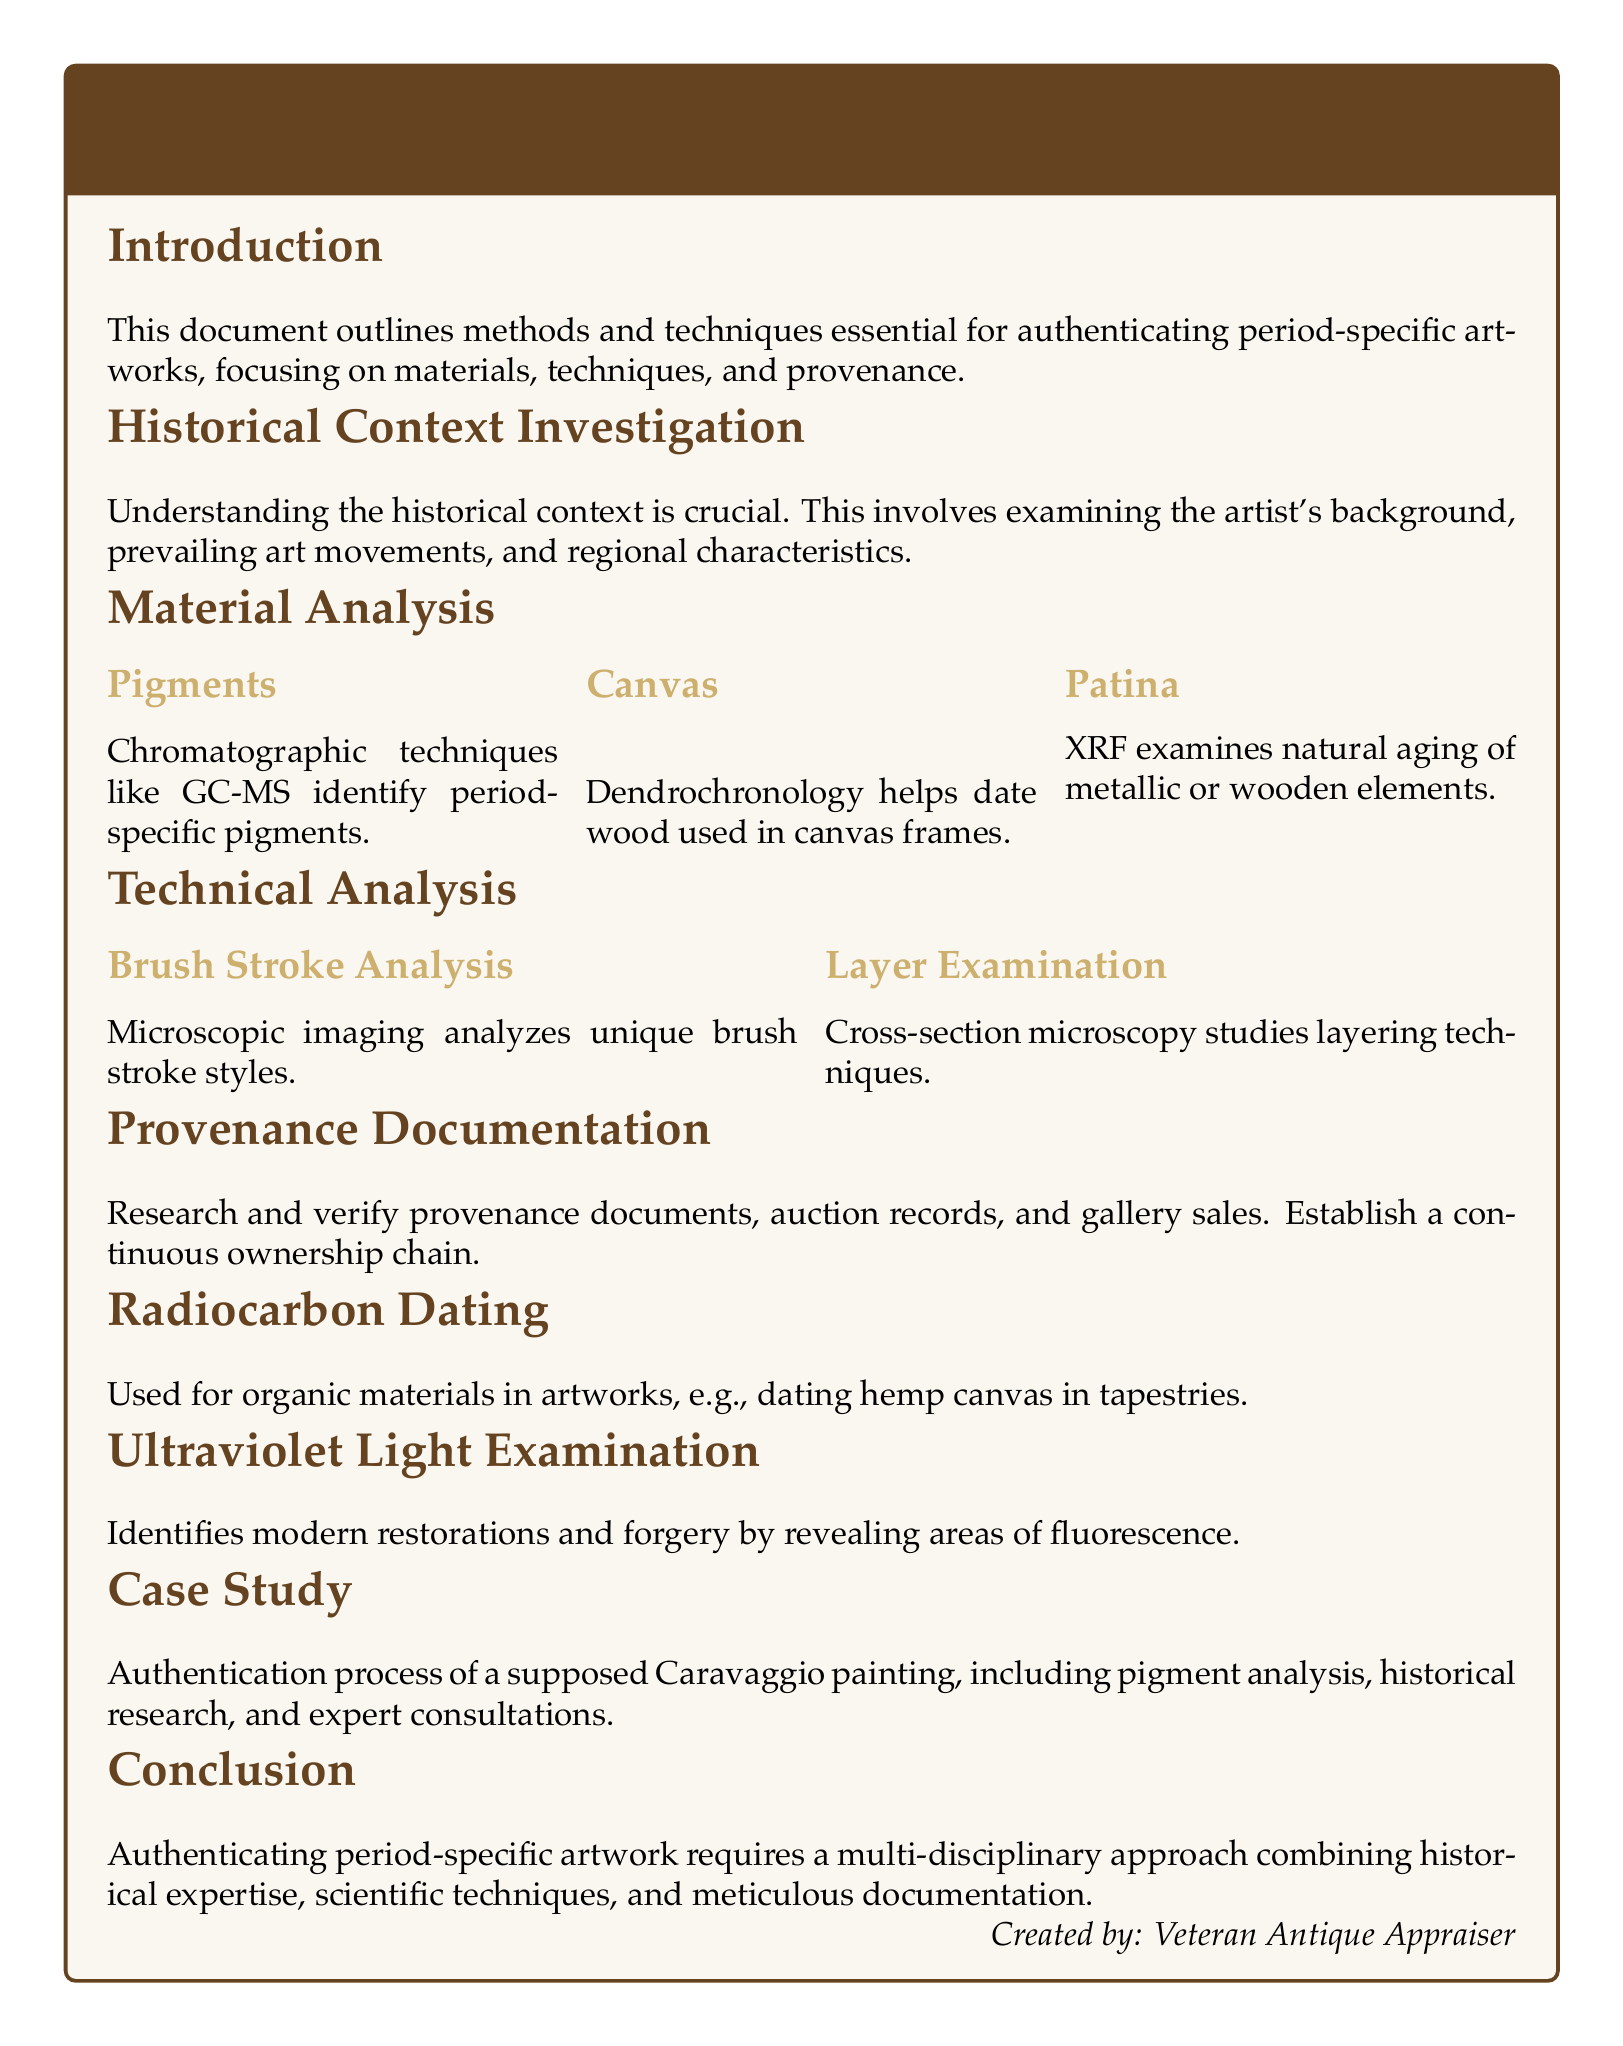What is the title of the document? The title of the document is displayed prominently at the beginning and is "Period-Specific Artwork Authentication Documentation and Technique Analysis."
Answer: Period-Specific Artwork Authentication Documentation and Technique Analysis What technique is used for pigment analysis? The document mentions that chromatographic techniques like GC-MS are used to identify period-specific pigments.
Answer: GC-MS Which method helps date wood used in canvas frames? Dendrochronology is identified as a method for dating wood in canvas frames.
Answer: Dendrochronology What does XRF analyze? According to the document, XRF examines the natural aging of metallic or wooden elements.
Answer: Natural aging What is the purpose of ultraviolet light examination? The document states that ultraviolet light examination identifies modern restorations and forgery by revealing areas of fluorescence.
Answer: Identify restorations and forgery What type of artwork can radiocarbon dating be used for? The document specifies that radiocarbon dating is used for organic materials in artworks, such as hemp canvas in tapestries.
Answer: Hemp canvas What kind of analysis is conducted on brush strokes? The document states that microscopic imaging is used to analyze unique brush stroke styles.
Answer: Microscopic imaging What is required in provenance documentation? The document mentions that provenance documentation requires research and verification of documents, auction records, and gallery sales.
Answer: Research and verification What is the main conclusion of the document? The document concludes that authenticating period-specific artwork requires a multi-disciplinary approach combining historical expertise, scientific techniques, and meticulous documentation.
Answer: Multi-disciplinary approach 